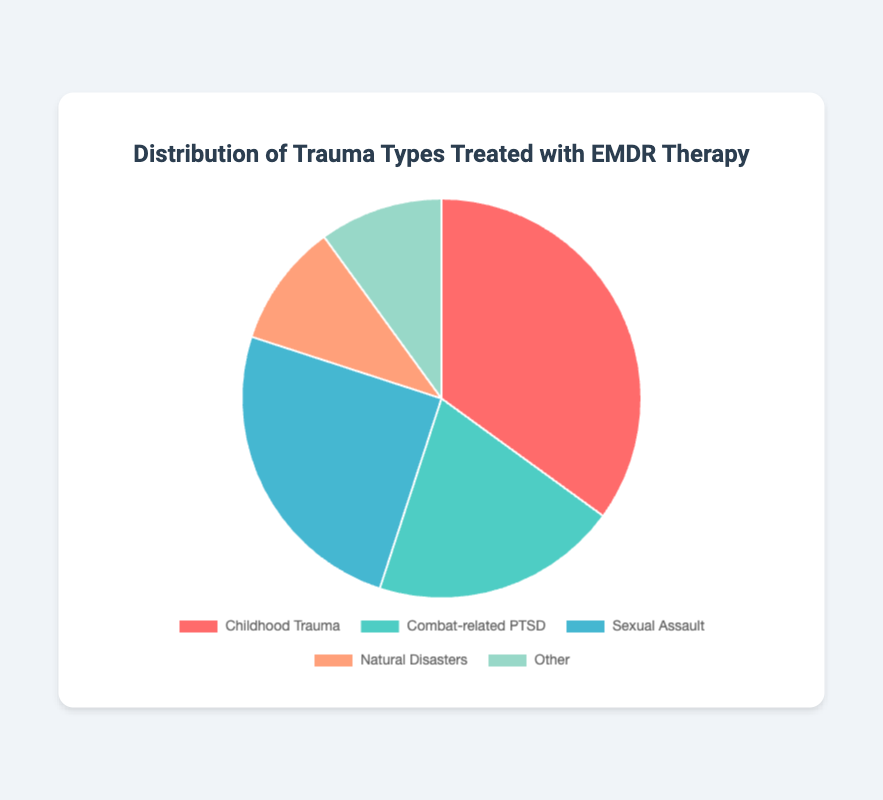What's the most common type of trauma treated with EMDR therapy? By looking at the pie chart, identify the segment with the largest area, which represents the highest percentage. Childhood Trauma has the largest segment at 35%.
Answer: Childhood Trauma Which two trauma types have the same percentage of treatment with EMDR therapy? Check the labels and their corresponding percentages. Both "Natural Disasters" and "Other" segments show 10%.
Answer: Natural Disasters and Other What is the total percentage of trauma types treated other than Childhood Trauma? Add up the percentages of all trauma types except Childhood Trauma. So, 20% (Combat-related PTSD) + 25% (Sexual Assault) + 10% (Natural Disasters) + 10% (Other) = 65%.
Answer: 65% How does the percentage of Sexual Assault compare to Combat-related PTSD? Compare the percentages directly. Sexual Assault is 25% and Combat-related PTSD is 20%. Hence, Sexual Assault is 5% higher than Combat-related PTSD.
Answer: Sexual Assault is higher by 5% Which trauma type is represented by the blue segment? Locate the blue color in the pie chart, which correlates with the labels. The blue segment represents Sexual Assault, which has 25%.
Answer: Sexual Assault What is the difference in percentage between the most and least common trauma types treated with EMDR therapy? Identify the highest (Childhood Trauma, 35%) and lowest percentages (Natural Disasters and Other, both 10%). Subtract the lowest from the highest: 35% - 10% = 25%.
Answer: 25% What percentage of the trauma types are classified as either Natural Disasters or Other? Add the percentages of both segments labeled Natural Disasters and Other. Both are 10% each, so 10% + 10% = 20%.
Answer: 20% If another category representing "Workplace Accidents" at 10% was added, how would this affect the total percentage for "Other"? Currently, "Other" is at 10%. Adding "Workplace Accidents" at 10% would double the generalized "Other" category from 10% to 20%. However, the pie chart would need adaptation to include this new category specifically.
Answer: 20% (hypothetical change) 